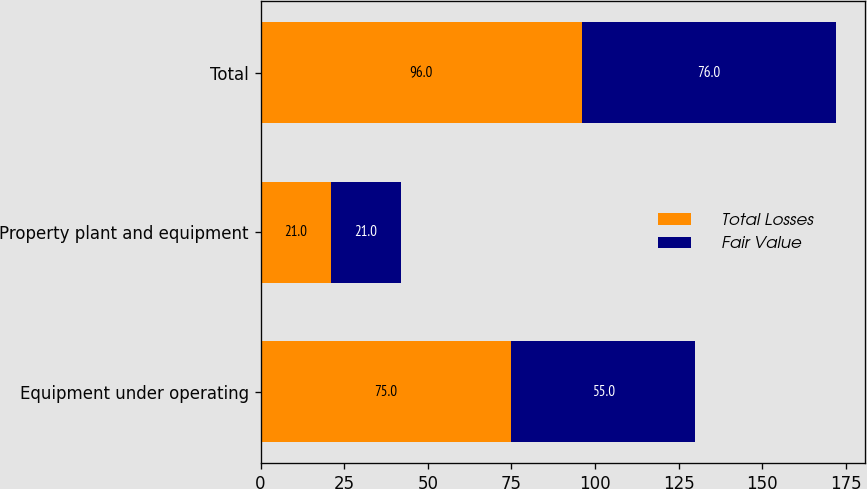<chart> <loc_0><loc_0><loc_500><loc_500><stacked_bar_chart><ecel><fcel>Equipment under operating<fcel>Property plant and equipment<fcel>Total<nl><fcel>Total Losses<fcel>75<fcel>21<fcel>96<nl><fcel>Fair Value<fcel>55<fcel>21<fcel>76<nl></chart> 